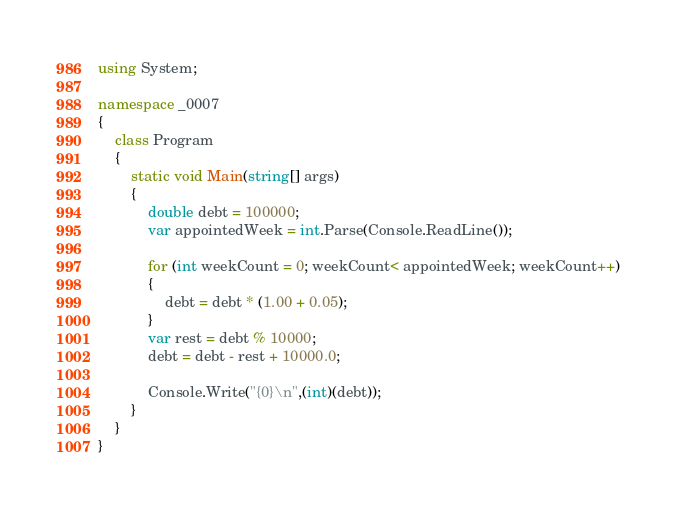<code> <loc_0><loc_0><loc_500><loc_500><_C#_>using System;

namespace _0007
{
    class Program
    {
        static void Main(string[] args)
        {
            double debt = 100000;
            var appointedWeek = int.Parse(Console.ReadLine());

            for (int weekCount = 0; weekCount< appointedWeek; weekCount++)
            {
                debt = debt * (1.00 + 0.05);
            }
            var rest = debt % 10000;
            debt = debt - rest + 10000.0;

            Console.Write("{0}\n",(int)(debt));
        }
    }
}</code> 